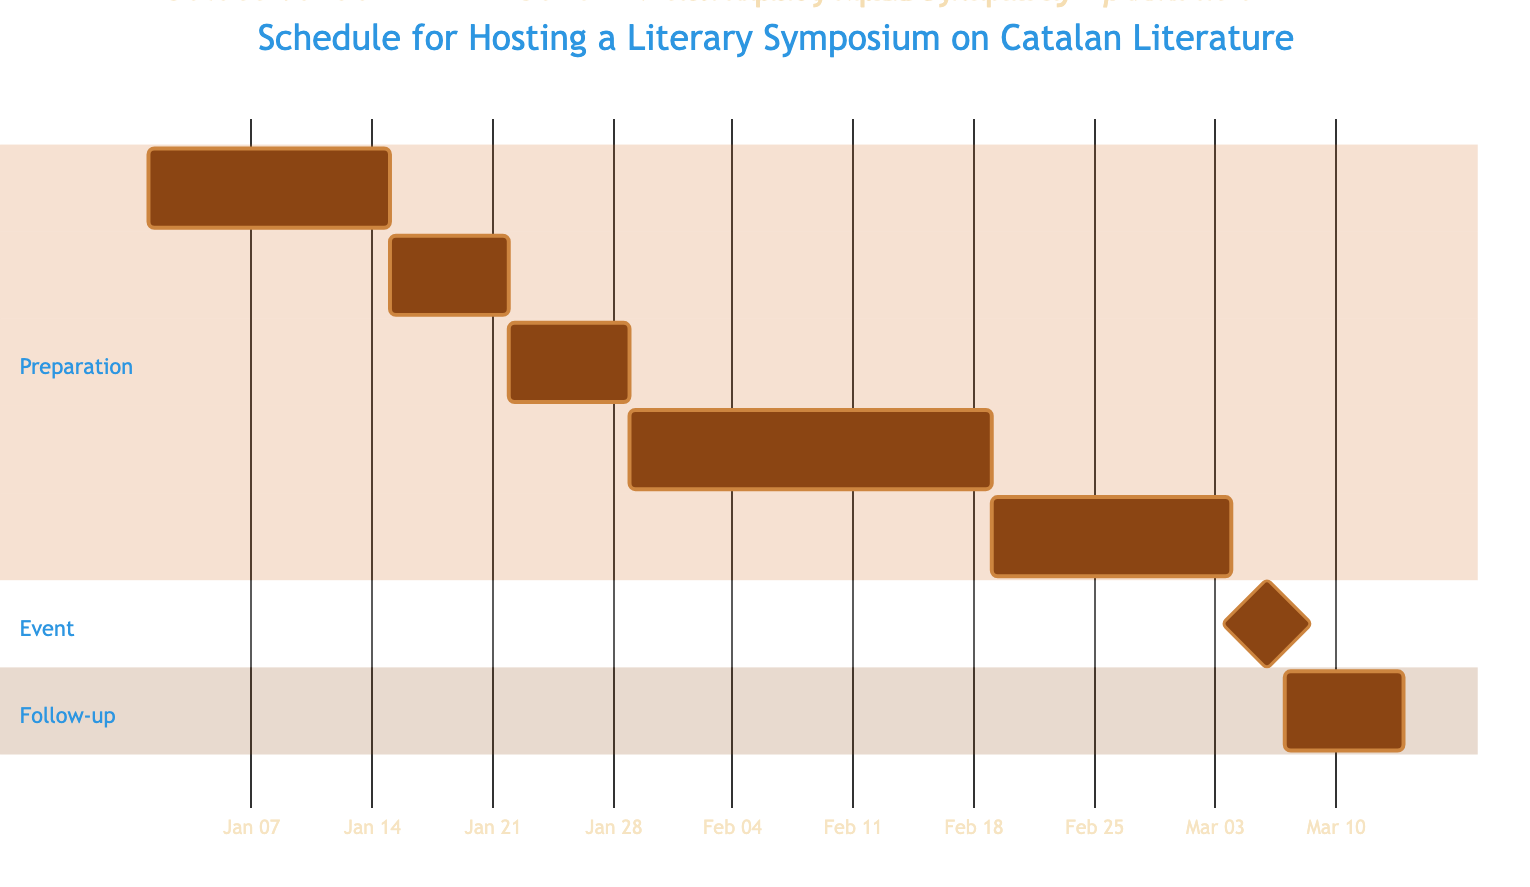What is the duration for sending invitations to speakers? The duration for sending invitations is specified as 1 week, directly indicated in the task section of the diagram.
Answer: 1 week How many tasks are included in the preparation section? The preparation section has five tasks listed: Select Venue, Send Invitations to Speakers, Finalize Symposium Schedule, Promote the Symposium, and Prepare Symposium Materials. Counting these gives a total of five tasks.
Answer: 5 When does the promotion of the symposium start? The promotion of the symposium starts after the Finalize Symposium Schedule task, which is completed on January 28, 2024. Therefore, the promotion begins on January 29, 2024.
Answer: January 29, 2024 What is the last task in the follow-up section? The last task in the follow-up section is the Post-Symposium Evaluation, which is the only task listed in that section.
Answer: Post-Symposium Evaluation What is the duration of the symposium? The duration of the symposium is specified as 2 days, marked by the Conduct Symposium task in the event section of the diagram.
Answer: 2 days Which task starts immediately after promoting the symposium? The task that starts immediately after promoting the symposium is Prepare Symposium Materials, which follows directly after the promotion duration of 3 weeks.
Answer: Prepare Symposium Materials How many weeks is the overall timeline from selecting the venue to conducting the symposium? The timeline starts on January 1, 2024, for selecting the venue and ends on March 6, 2024, with the conduct of the symposium. The total duration is 9 weeks, which is calculated by counting all tasks and their respective processing times.
Answer: 9 weeks What is the relationship between conducting the symposium and post-symposium evaluation? Conducting the symposium serves as a milestone completion, after which the Post-Symposium Evaluation begins, creating a sequential relationship where the evaluation task follows directly after the symposium.
Answer: Sequential relationship 